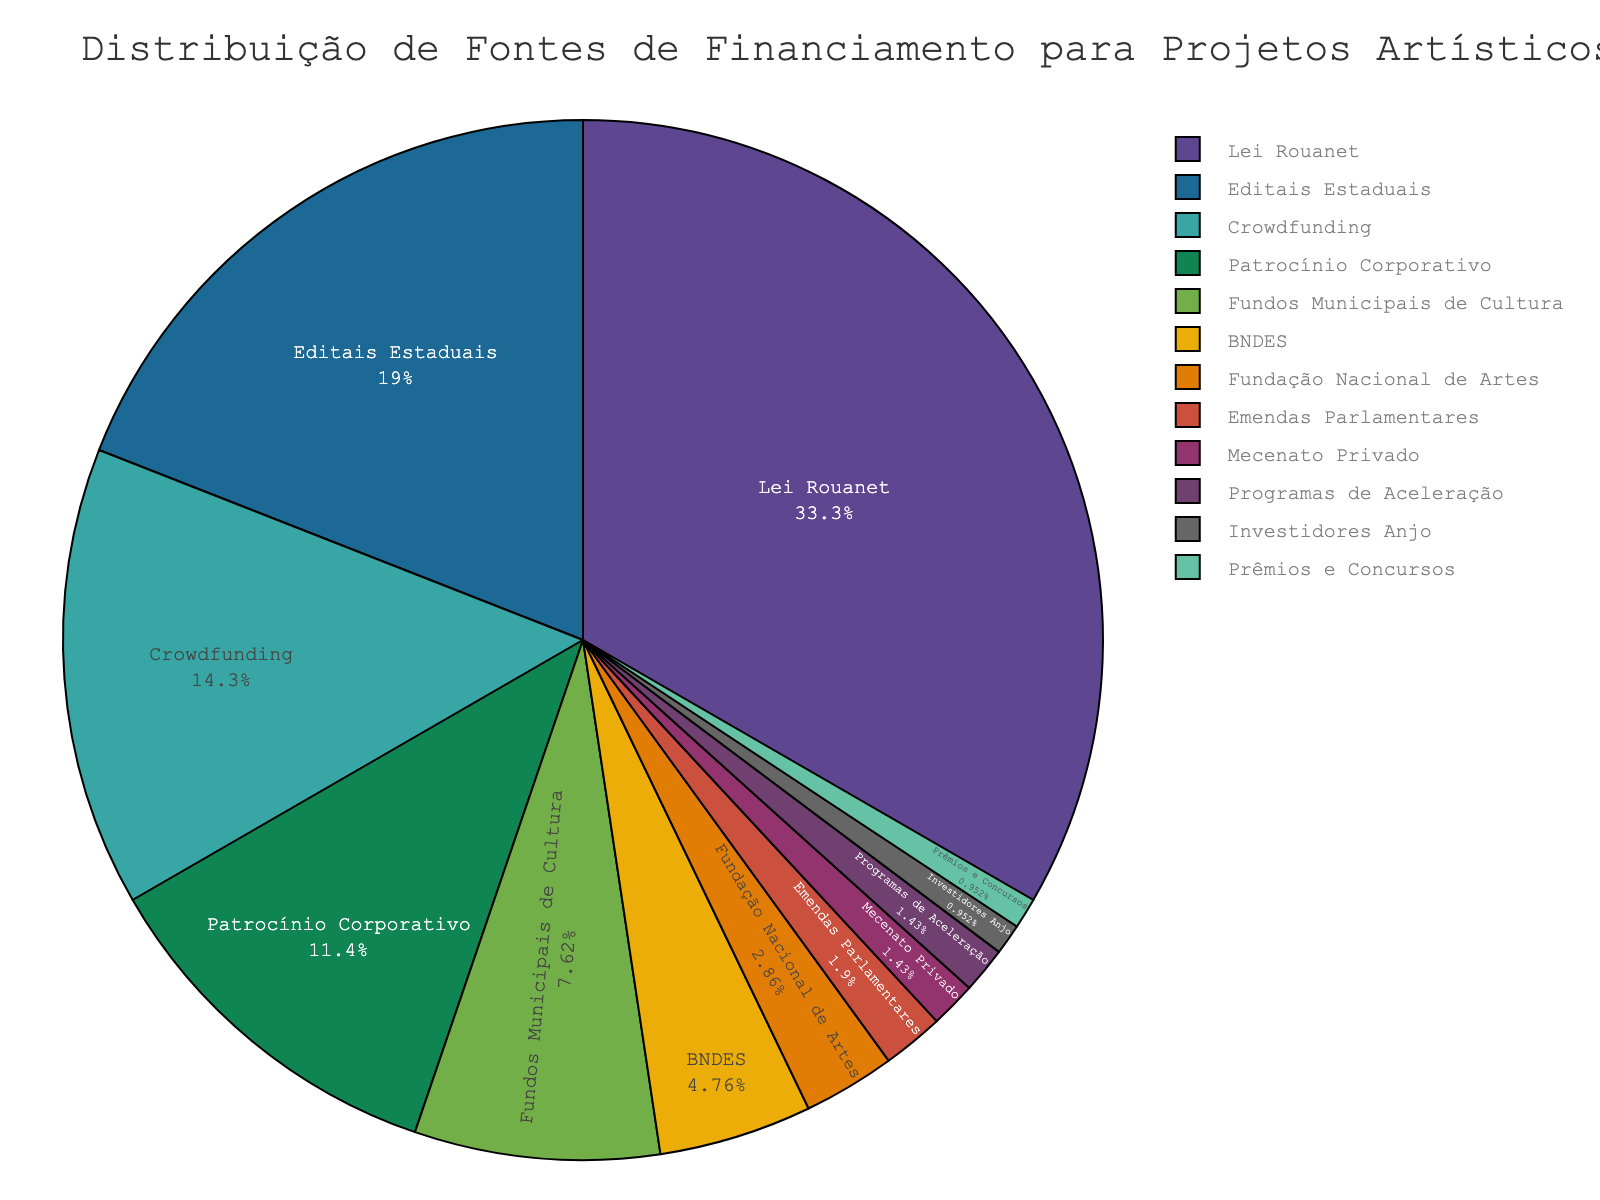Qual fonte de financiamento tem a maior porcentagem? A figura mostra que a "Lei Rouanet" ocupa a maior parte do gráfico de pizza. A legenda confirma que a maior fatia corresponde a 35%.
Answer: Lei Rouanet Qual é a segunda maior fonte de financiamento? Observando o gráfico, podemos ver que a segunda maior fatia corresponde a "Editais Estaduais", que ocupa 20% do total.
Answer: Editais Estaduais Qual é a soma das porcentagens das três menores fontes de financiamento? As três menores fontes são "Mecenato Privado" (1.5%), "Programas de Aceleração" (1.5%) e "Investidores Anjo" (1%). Somando essas porcentagens: 1.5% + 1.5% + 1% = 4%.
Answer: 4% Quantas fontes possuem uma porcentagem inferior a 5%? Identificamos as fontes com porcentagens inferiores a 5% no gráfico: "Fundação Nacional de Artes" (3%), "Emendas Parlamentares" (2%), "Mecenato Privado" (1.5%), "Programas de Aceleração" (1.5%), "Investidores Anjo" (1%), e "Prêmios e Concursos" (1%). No total, isso soma 6 fontes.
Answer: 6 Comparando "Crowdfunding" e "Patrocínio Corporativo", qual é maior e por quanto? "Crowdfunding" tem 15% e "Patrocínio Corporativo" tem 12%. 15% - 12% = 3%. Portanto, "Crowdfunding" é 3% maior que "Patrocínio Corporativo".
Answer: Crowdfunding por 3% Qual a diferença de porcentagem entre "Fundos Municipais de Cultura" e "BNDES"? "Fundos Municipais de Cultura" tem 8% e "BNDES" tem 5%. A diferença é 8% - 5% = 3%.
Answer: 3% Qual cor representa a fatia da "Lei Rouanet"? Analisando a paleta de cores no gráfico, podemos observar que a fatia da "Lei Rouanet" é destacada com a cor mais vibrante, que é vermelha.
Answer: Vermelha Se "Prêmios e Concursos" aumenta em 2%, qual seria a nova porcentagem total? "Prêmios e Concursos" atualmente está em 1%. Se aumentar em 2%, então a nova porcentagem seria 1% + 2% = 3%.
Answer: 3% Qual segmento tem a menor porcentagem e qual é essa porcentagem? O segmento "Prêmios e Concursos" é o que tem a menor porcentagem no gráfico, que é 1%.
Answer: Prêmios e Concursos, 1% Se somarmos a porcentagem de "Lei Rouanet", "Editais Estaduais" e "Crowdfunding", qual é o resultado? Calculando a soma: "Lei Rouanet" (35%) + "Editais Estaduais" (20%) + "Crowdfunding" (15%). 35% + 20% + 15% = 70%.
Answer: 70% 